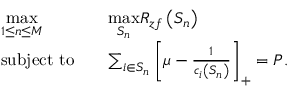<formula> <loc_0><loc_0><loc_500><loc_500>\begin{array} { r l r l } & { \underset { 1 \leq n \leq M } { \max } } & & { \underset { S _ { n } } { \max } R _ { z f } \left ( S _ { n } \right ) } \\ & { s u b j e c t t o } & & { \sum _ { i \in S _ { n } } \left [ \mu - \frac { 1 } { c _ { i } \left ( S _ { n } \right ) } \right ] _ { + } = P . } \end{array}</formula> 